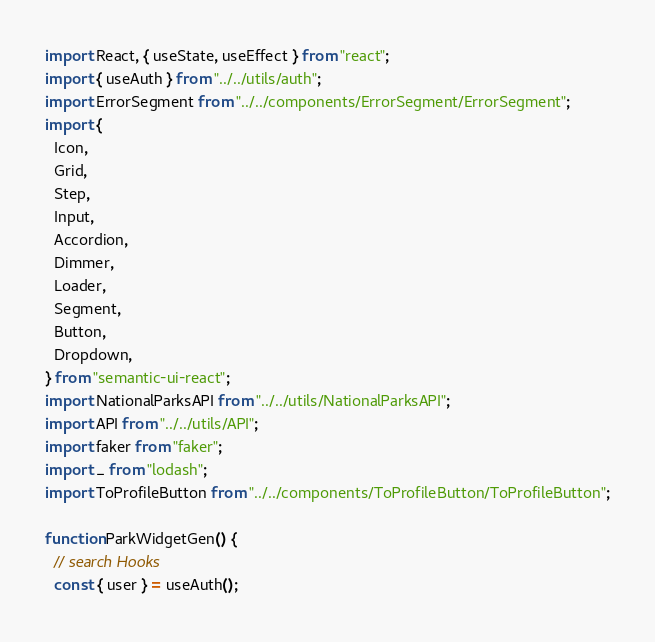<code> <loc_0><loc_0><loc_500><loc_500><_JavaScript_>import React, { useState, useEffect } from "react";
import { useAuth } from "../../utils/auth";
import ErrorSegment from "../../components/ErrorSegment/ErrorSegment";
import {
  Icon,
  Grid,
  Step,
  Input,
  Accordion,
  Dimmer,
  Loader,
  Segment,
  Button,
  Dropdown,
} from "semantic-ui-react";
import NationalParksAPI from "../../utils/NationalParksAPI";
import API from "../../utils/API";
import faker from "faker";
import _ from "lodash";
import ToProfileButton from "../../components/ToProfileButton/ToProfileButton";

function ParkWidgetGen() {
  // search Hooks
  const { user } = useAuth();</code> 